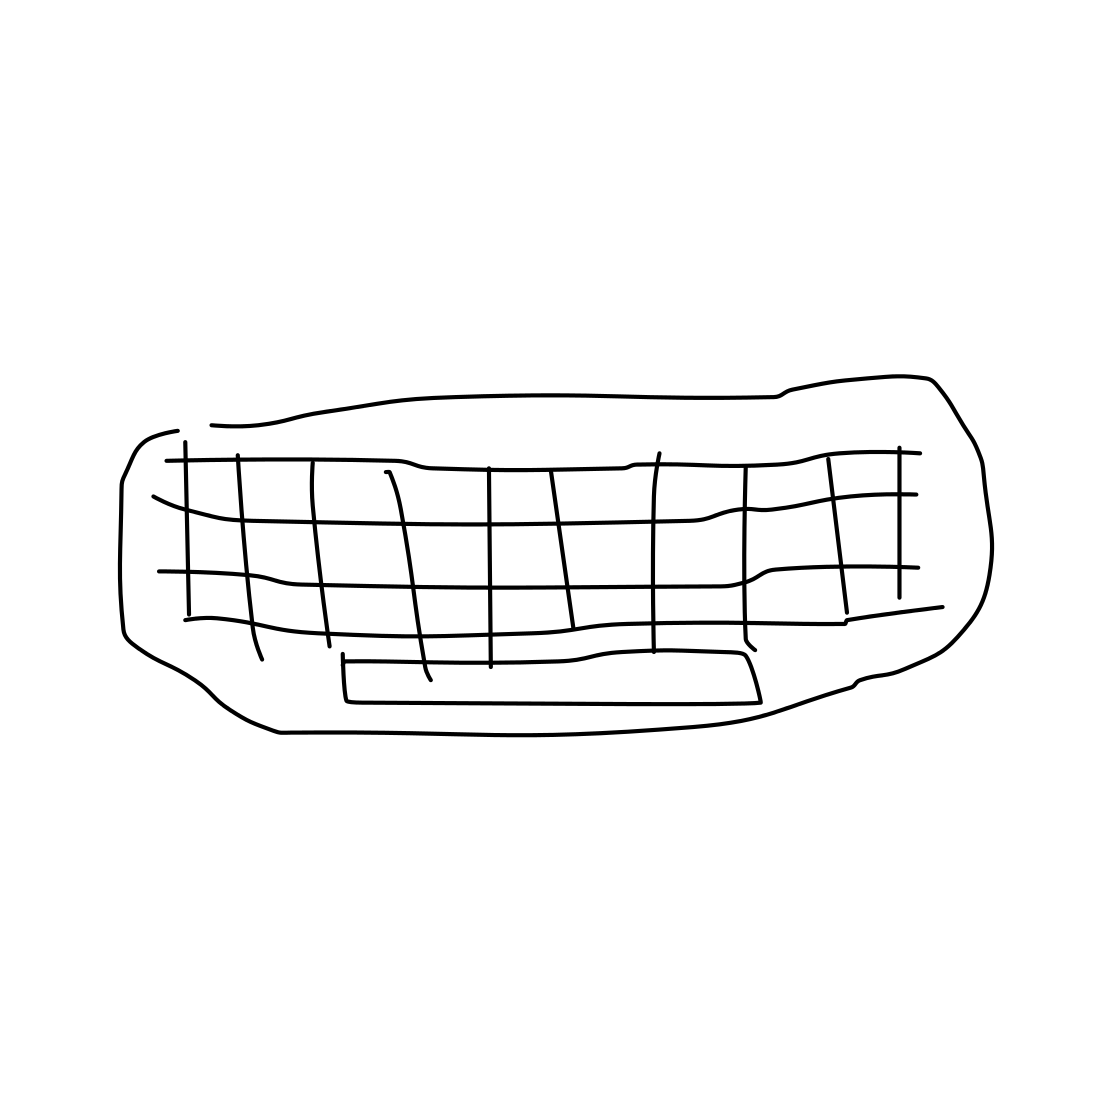Could you describe the style of this drawing? Certainly. This is a minimalistic and abstract representation of a couch, using only outlines and a grid pattern to convey its form. 